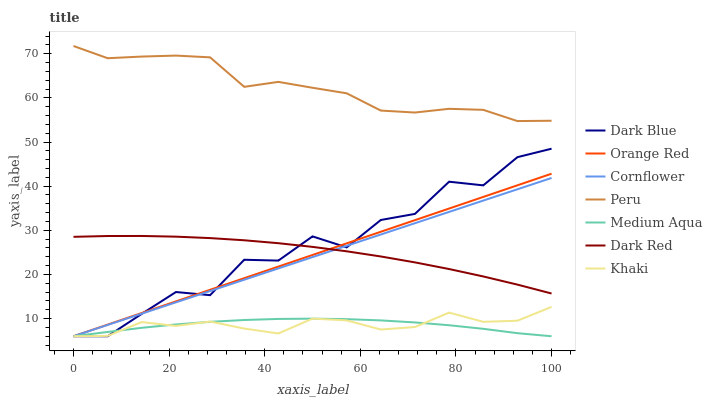Does Medium Aqua have the minimum area under the curve?
Answer yes or no. Yes. Does Peru have the maximum area under the curve?
Answer yes or no. Yes. Does Khaki have the minimum area under the curve?
Answer yes or no. No. Does Khaki have the maximum area under the curve?
Answer yes or no. No. Is Orange Red the smoothest?
Answer yes or no. Yes. Is Dark Blue the roughest?
Answer yes or no. Yes. Is Khaki the smoothest?
Answer yes or no. No. Is Khaki the roughest?
Answer yes or no. No. Does Cornflower have the lowest value?
Answer yes or no. Yes. Does Dark Red have the lowest value?
Answer yes or no. No. Does Peru have the highest value?
Answer yes or no. Yes. Does Khaki have the highest value?
Answer yes or no. No. Is Khaki less than Dark Red?
Answer yes or no. Yes. Is Peru greater than Orange Red?
Answer yes or no. Yes. Does Dark Red intersect Cornflower?
Answer yes or no. Yes. Is Dark Red less than Cornflower?
Answer yes or no. No. Is Dark Red greater than Cornflower?
Answer yes or no. No. Does Khaki intersect Dark Red?
Answer yes or no. No. 